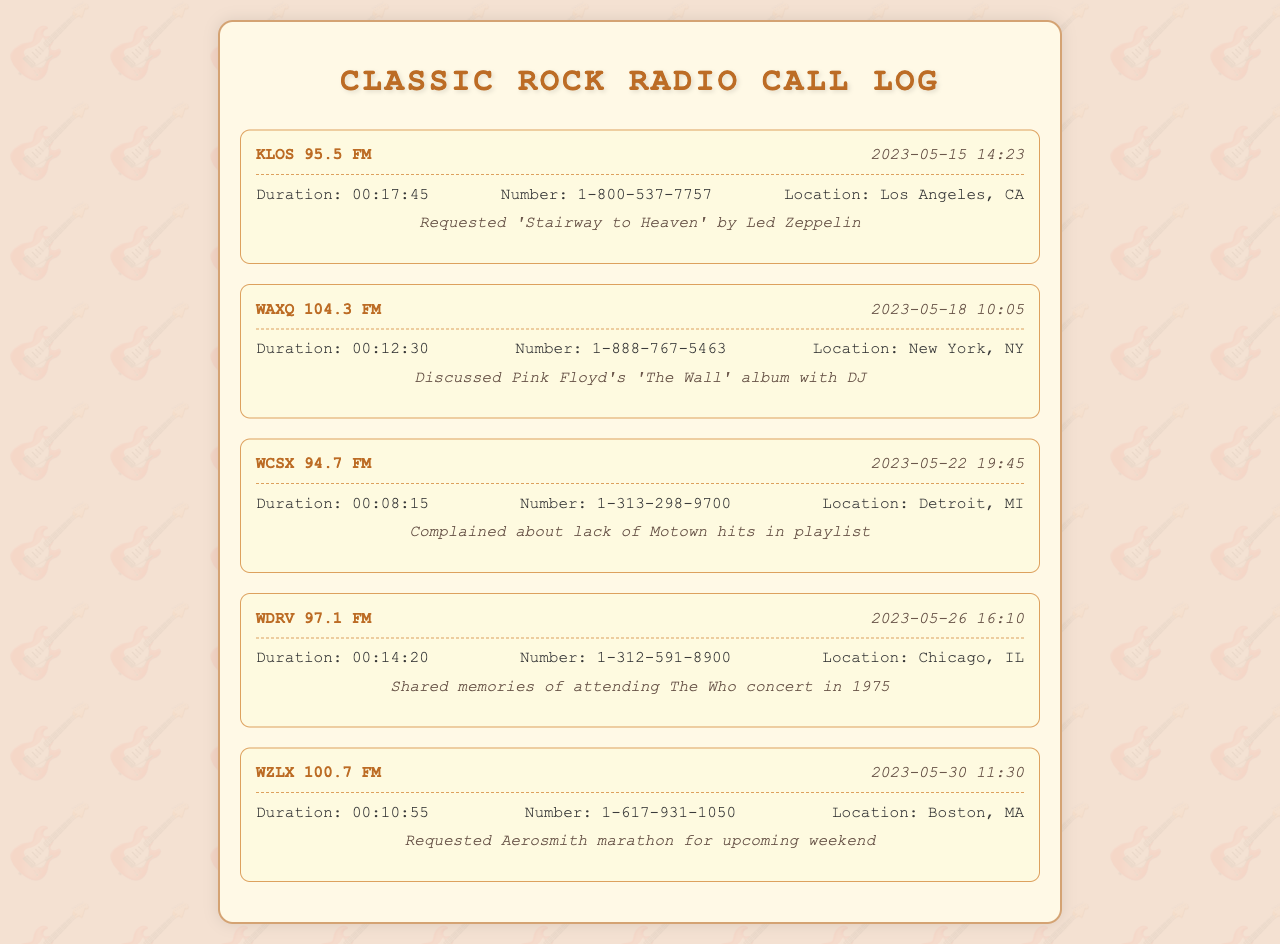what is the date of the call to KLOS? The call to KLOS 95.5 FM occurred on May 15, 2023.
Answer: May 15, 2023 what was the duration of the call to WAXQ? The duration of the call to WAXQ 104.3 FM was 12 minutes and 30 seconds.
Answer: 00:12:30 which city is associated with WCSX? WCSX 94.7 FM is associated with Detroit.
Answer: Detroit who did the caller discuss with on May 18? The caller discussed Pink Floyd's album with the DJ on May 18.
Answer: DJ how many seconds did the call to WDRV last? The call to WDRV lasted 860 seconds, which is 14 minutes and 20 seconds.
Answer: 860 seconds what was the main complaint during the call to WCSX? The caller complained about the lack of Motown hits in the playlist.
Answer: Lack of Motown hits what song was requested during the call to KLOS? The song requested during the call to KLOS was 'Stairway to Heaven' by Led Zeppelin.
Answer: 'Stairway to Heaven' which radio station was contacted for an Aerosmith marathon? The station contacted for an Aerosmith marathon was WZLX 100.7 FM.
Answer: WZLX 100.7 FM 